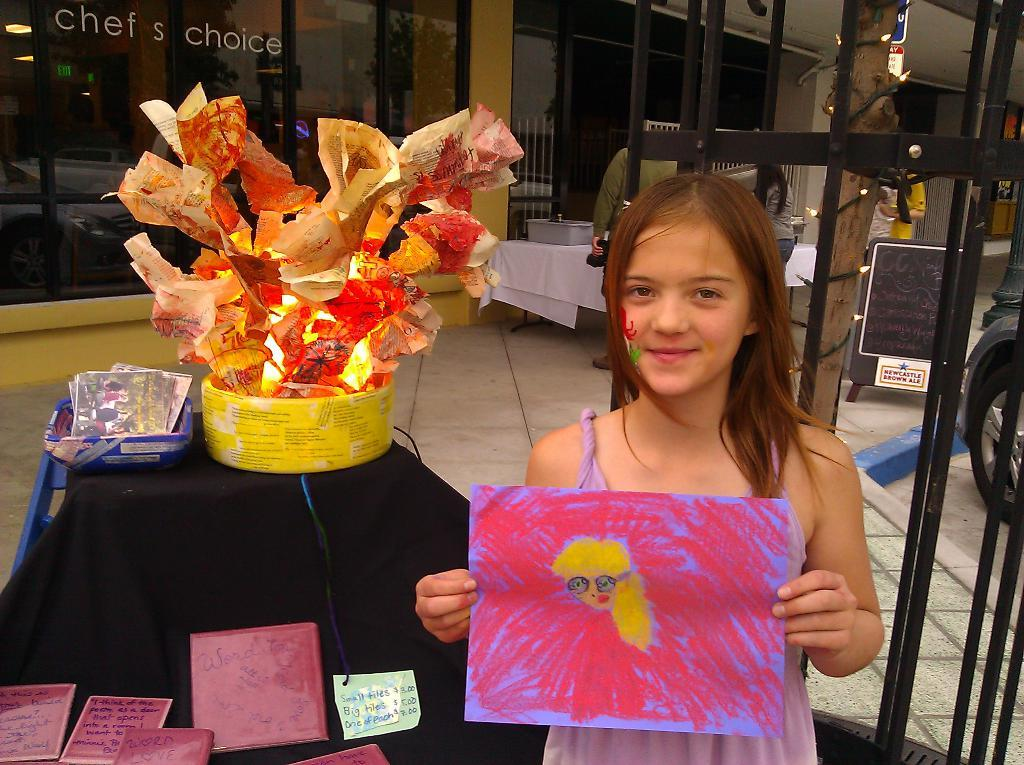What is the main subject of the image? The main subject of the image is a kid standing. What is the kid holding in her hands? The kid is holding a paper in her hands. What can be seen on the paper? There is a drawing on the paper. What else can be seen in the background of the image? There are other objects visible behind the kid. What type of fog can be seen in the image? There is no fog present in the image. What answer is the kid providing on the paper? The provided facts do not mention any specific answer on the paper, only that there is a drawing. 